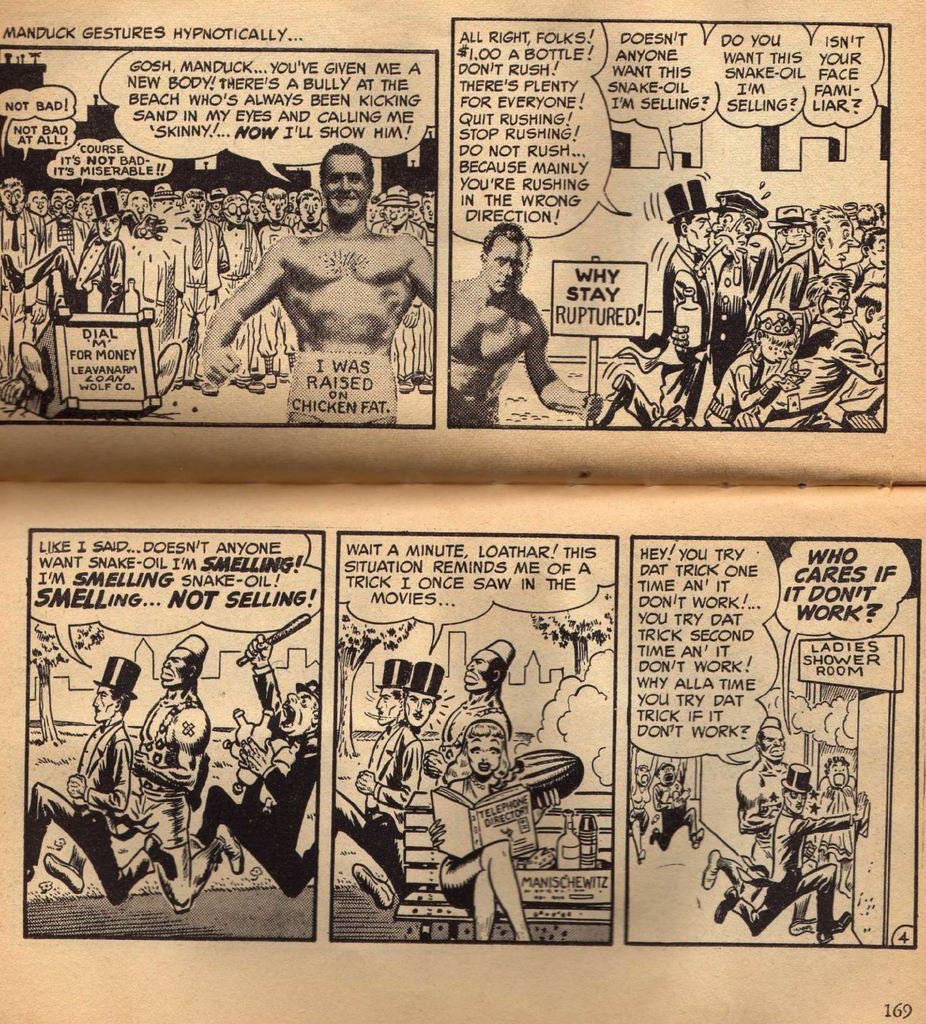<image>
Give a short and clear explanation of the subsequent image. a comic book page with a sign saying why stay ruptured! 